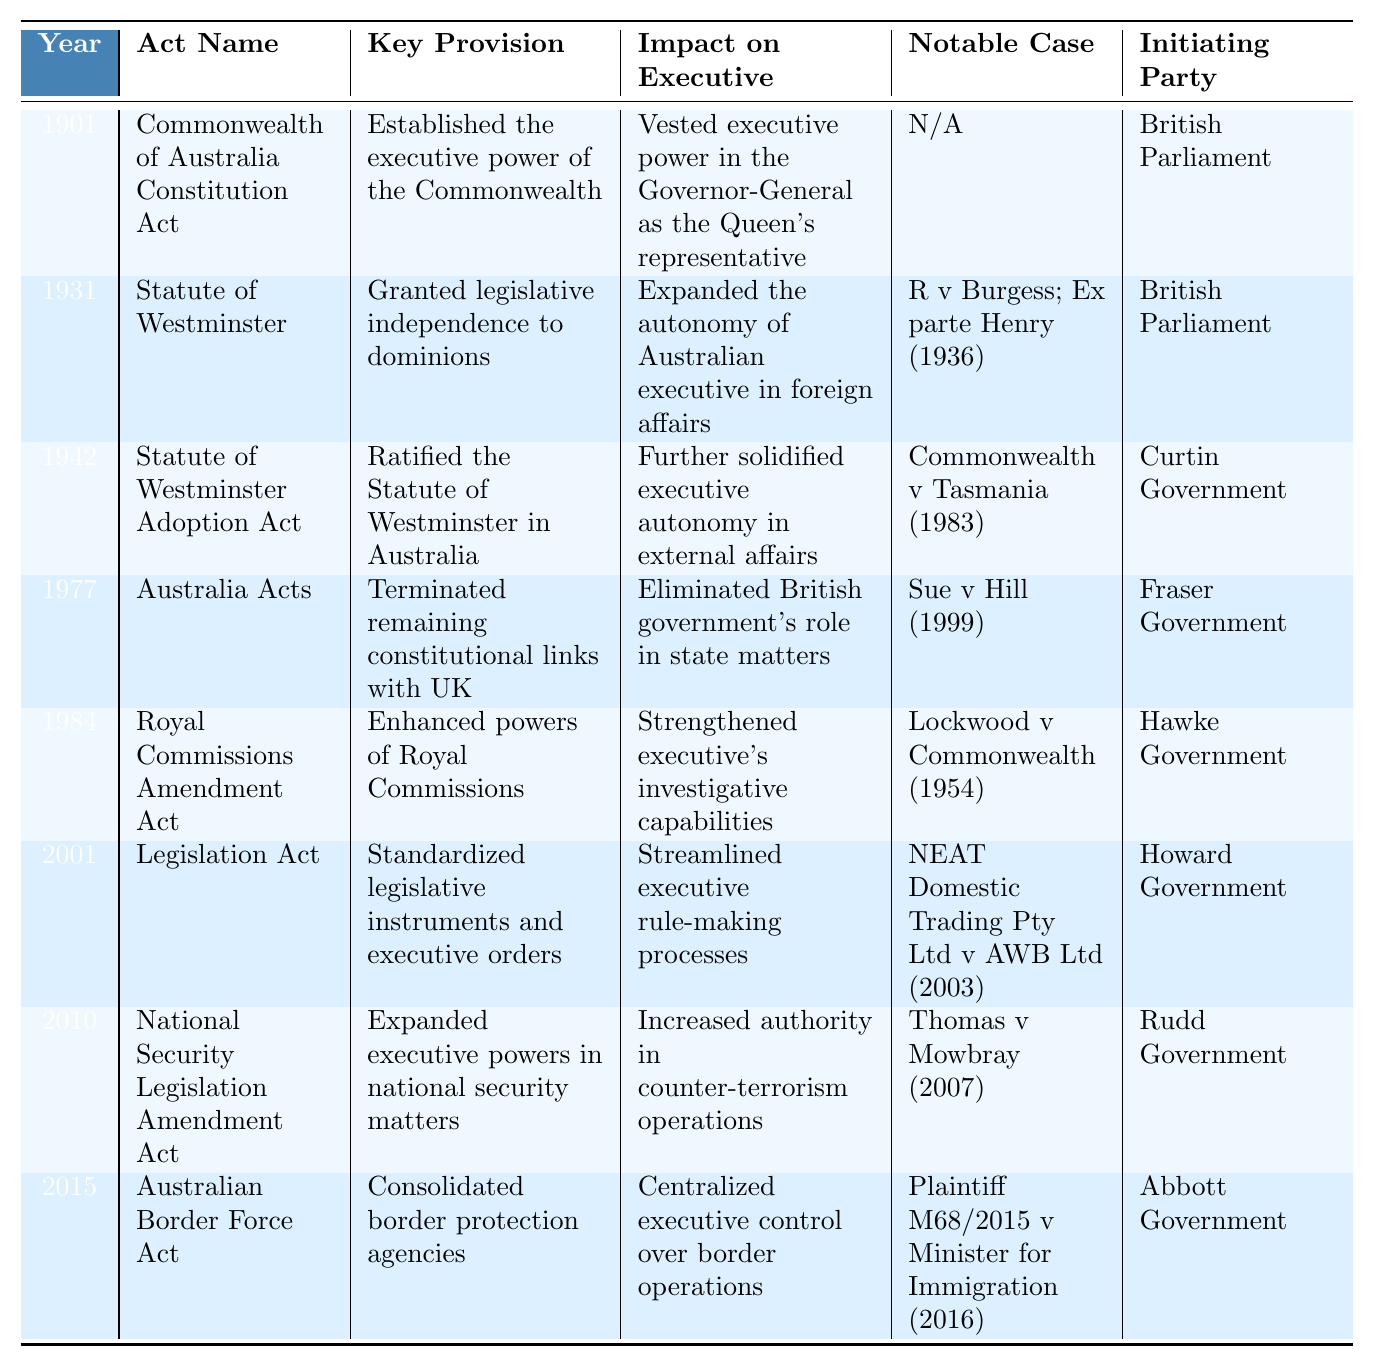What year was the Commonwealth of Australia Constitution Act enacted? The table lists the Commonwealth of Australia Constitution Act under the year 1901.
Answer: 1901 Which act expanded the autonomy of the Australian executive in foreign affairs? According to the table, the Statute of Westminster enacted in 1931 is noted for expanding the autonomy of the Australian executive in foreign affairs.
Answer: Statute of Westminster What notable case is associated with the 1942 Statute of Westminster Adoption Act? The table indicates that the notable case linked to the Statute of Westminster Adoption Act from 1942 is Commonwealth v Tasmania (1983).
Answer: Commonwealth v Tasmania (1983) How many acts were initiated by the British Parliament? By examining the table, three acts (Commonwealth of Australia Constitution Act, Statute of Westminster, Statute of Westminster Adoption Act) were initiated by the British Parliament.
Answer: 3 Which act strengthened the executive's investigative capabilities? The Royal Commissions Amendment Act of 1984, according to the table, is noted for enhancing the powers of Royal Commissions, thus strengthening executive investigative capabilities.
Answer: Royal Commissions Amendment Act What is the significant impact of the Australia Acts passed in 1977? The table specifies that the Australia Acts eliminated the British government's role in state matters, marking a significant impact on the executive.
Answer: Eliminated British government's role Which act initiated by the Abbott Government pertains to border protection? The Australian Border Force Act from 2015, as indicated in the table, pertains to consolidating border protection agencies, initiated by the Abbott Government.
Answer: Australian Border Force Act What was the key provision of the Legislation Act of 2001? The Legislation Act of 2001 standardized legislative instruments and executive orders, according to the details in the table.
Answer: Standardized legislative instruments Identify a notable case linked to the National Security Legislation Amendment Act. The table shows that the notable case associated with the National Security Legislation Amendment Act of 2010 is Thomas v Mowbray (2007).
Answer: Thomas v Mowbray (2007) How many acts were enacted after 1980 and what were their initiators? Reviewing the table, four acts (Royal Commissions Amendment Act 1984 by Hawke Government, Legislation Act 2001 by Howard Government, National Security Legislation Amendment Act 2010 by Rudd Government, Australian Border Force Act 2015 by Abbott Government) were enacted after 1980.
Answer: 4 acts; Hawke, Howard, Rudd, Abbott Governments Does the Statute of Westminster have any notable case linked to it? Yes, the table indicates that R v Burgess; Ex parte Henry (1936) is a notable case linked to the Statute of Westminster.
Answer: Yes 